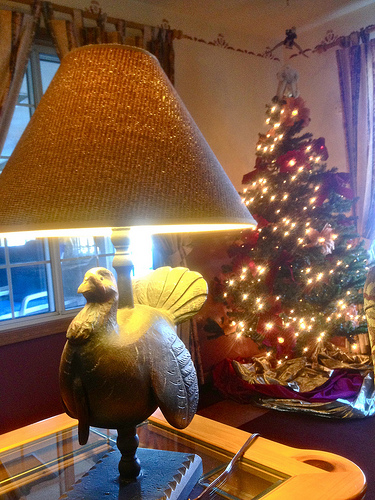<image>
Is the turkey under the lamp? Yes. The turkey is positioned underneath the lamp, with the lamp above it in the vertical space. 